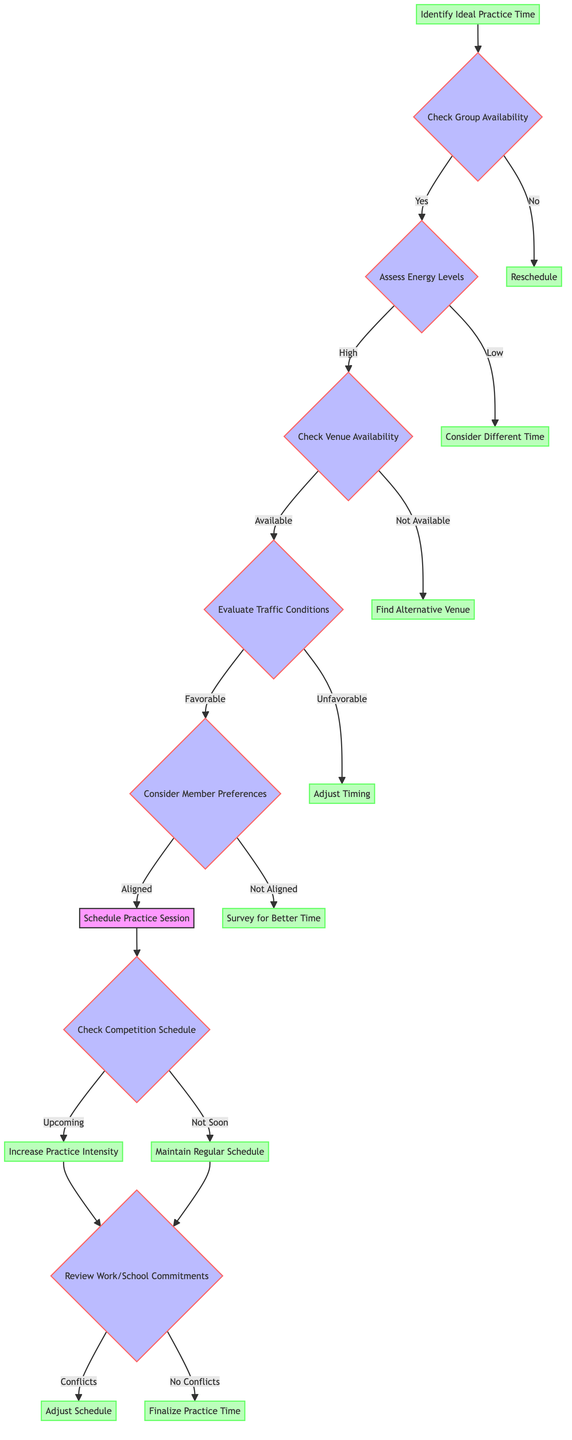What is the first decision point in the diagram? The first decision point is to check group availability, which is the node "Check Group Availability" directly connected to the starting node "Identify Ideal Practice Time."
Answer: Check Group Availability How many options are there after assessing energy levels? After assessing energy levels, there are two options: if energy levels are high or low, leading to different subsequent nodes, which totals two options.
Answer: Two What is the outcome if the venue is not available? If the venue is not available, the next step is to find an alternative venue, which is represented by the node "Find Alternative Venue" connected to the node "Check Venue Availability."
Answer: Find Alternative Venue In the event of conflicting work or school commitments, what action is suggested? If there are conflicts due to work or school commitments, the suggested action is to adjust the schedule, as indicated by the node "Adjust Schedule" connected to "Review Work/School Commitments."
Answer: Adjust Schedule What happens if the practice session time is not aligned with member preferences? If the practice session time is not aligned with member preferences, the action is to survey for a better time, represented by the node "Survey for Better Time."
Answer: Survey for Better Time What is the action taken if practice intensity needs to be increased? If practice intensity needs to be increased due to an upcoming competition, the diagram directs to increase practice intensity, represented by the node "Increase Practice Intensity."
Answer: Increase Practice Intensity How many end nodes are present in this decision tree? The decision tree contains six end nodes that represent outcomes based on the paths taken through the tree.
Answer: Six What is the primary factor considered before scheduling a practice session? The primary factor considered before scheduling a practice session is member preferences, indicated by the node "Consider Member Preferences."
Answer: Member Preferences What leads to the decision to maintain a regular schedule? The decision to maintain a regular schedule is reached if there are no upcoming competitions, as indicated by the node "Not Soon" leading to "Maintain Regular Schedule."
Answer: Maintain Regular Schedule 